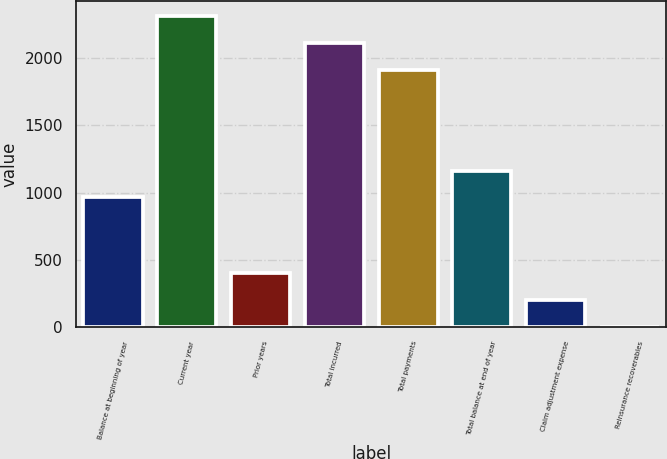<chart> <loc_0><loc_0><loc_500><loc_500><bar_chart><fcel>Balance at beginning of year<fcel>Current year<fcel>Prior years<fcel>Total incurred<fcel>Total payments<fcel>Total balance at end of year<fcel>Claim adjustment expense<fcel>Reinsurance recoverables<nl><fcel>964.3<fcel>2308.34<fcel>402.34<fcel>2109.32<fcel>1910.3<fcel>1163.32<fcel>203.32<fcel>4.3<nl></chart> 